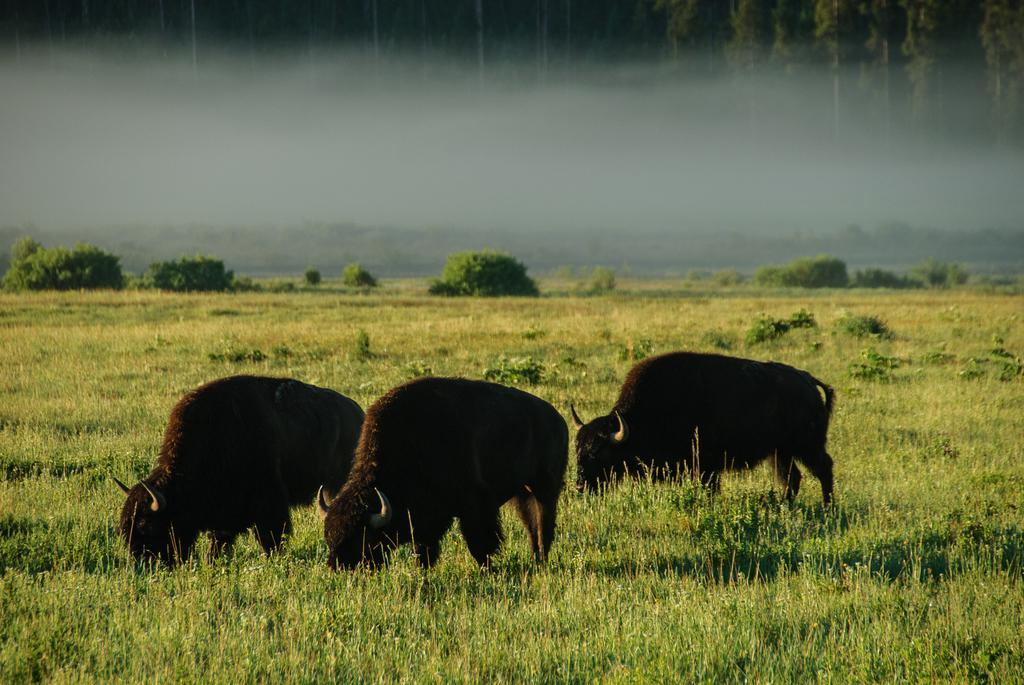Can you describe this image briefly? Here we can see animals on the ground. This is grass and there are plants. There is a blur background with greenery. 